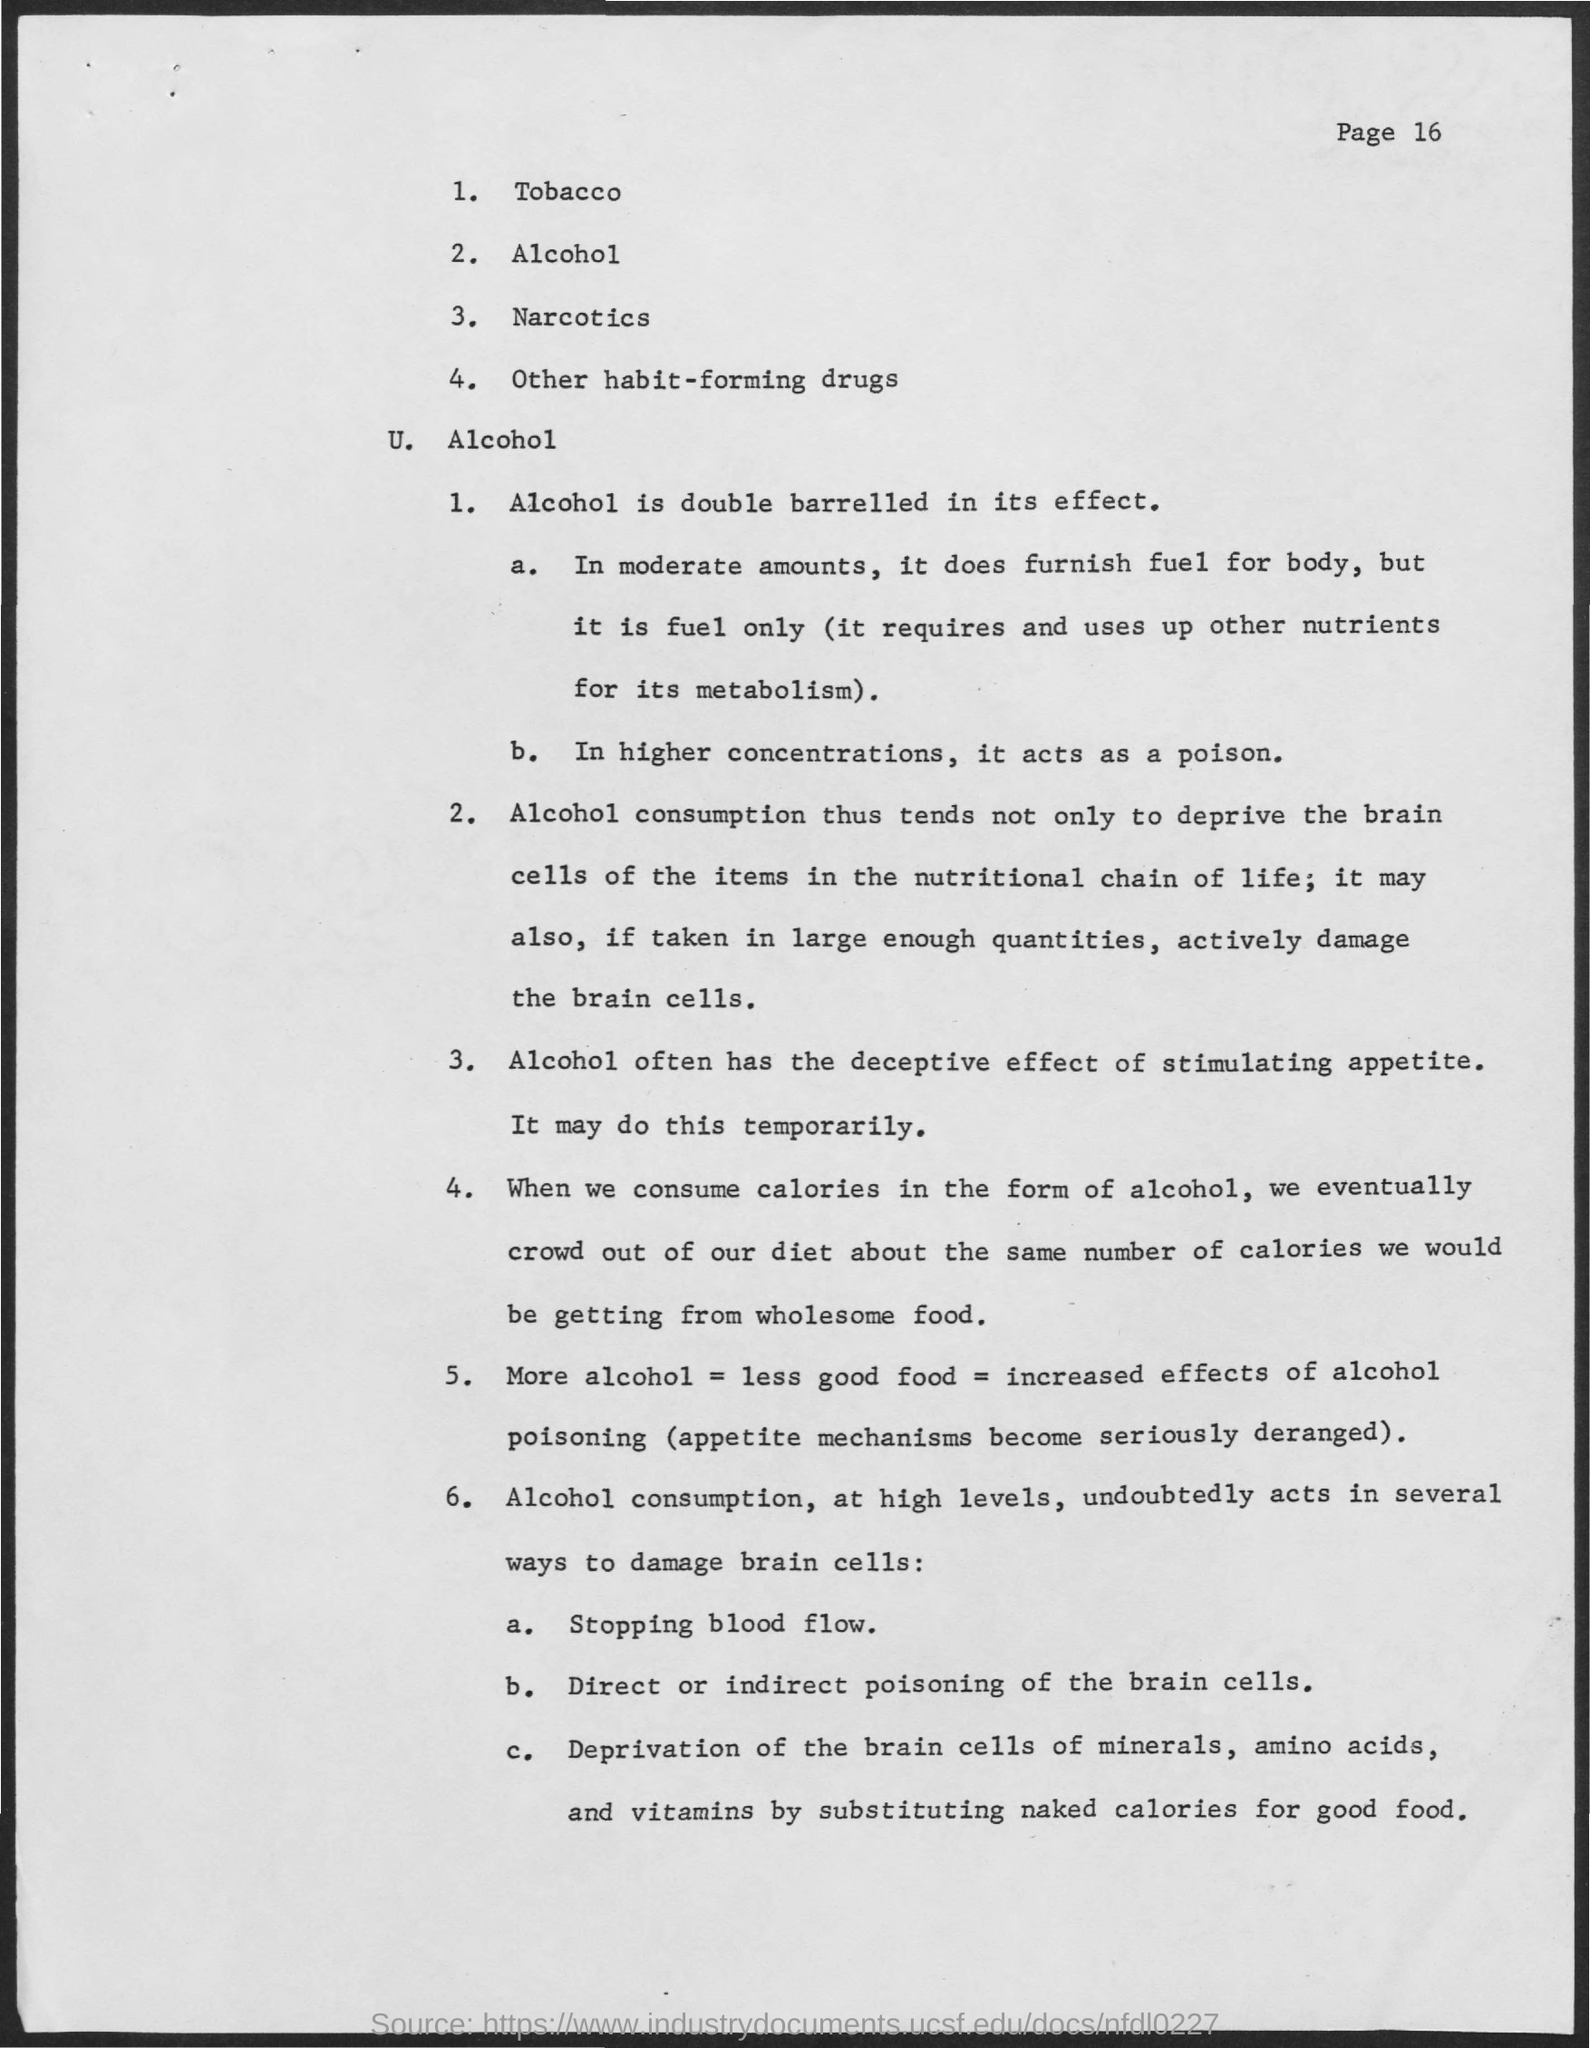Outline some significant characteristics in this image. Alcohol has a deceptive effect on appetite, stimulating it despite the fact that it is actually a depressant that slows down the digestive system. Alcohol, in its effect, is double barreled. High levels of alcohol consumption can cause the deprivation of brain cells, which are necessary for the proper functioning of all essential nutrients, including minerals, amino acids, and vitamins. In higher concentrations, alcohol acts as a poison. The page number at the top right corner of the page is 16, as declared. 